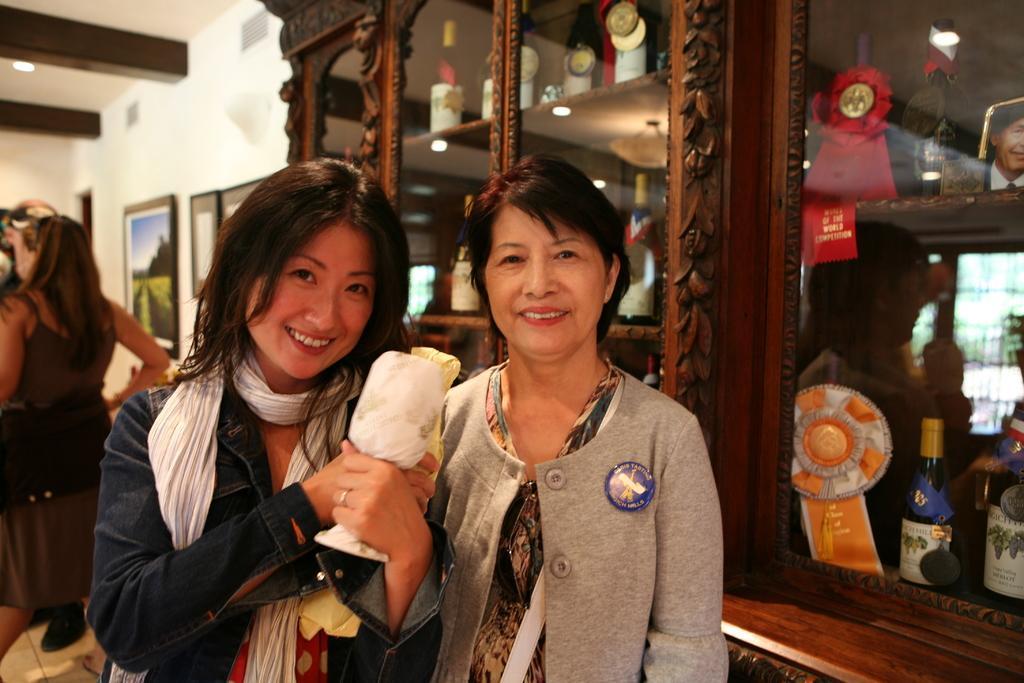In one or two sentences, can you explain what this image depicts? In this image there are people. In the background there is a cupboard and we can see things placed in the cupboard. There is a wall and we can see frames placed on the wall. We can see a light. 